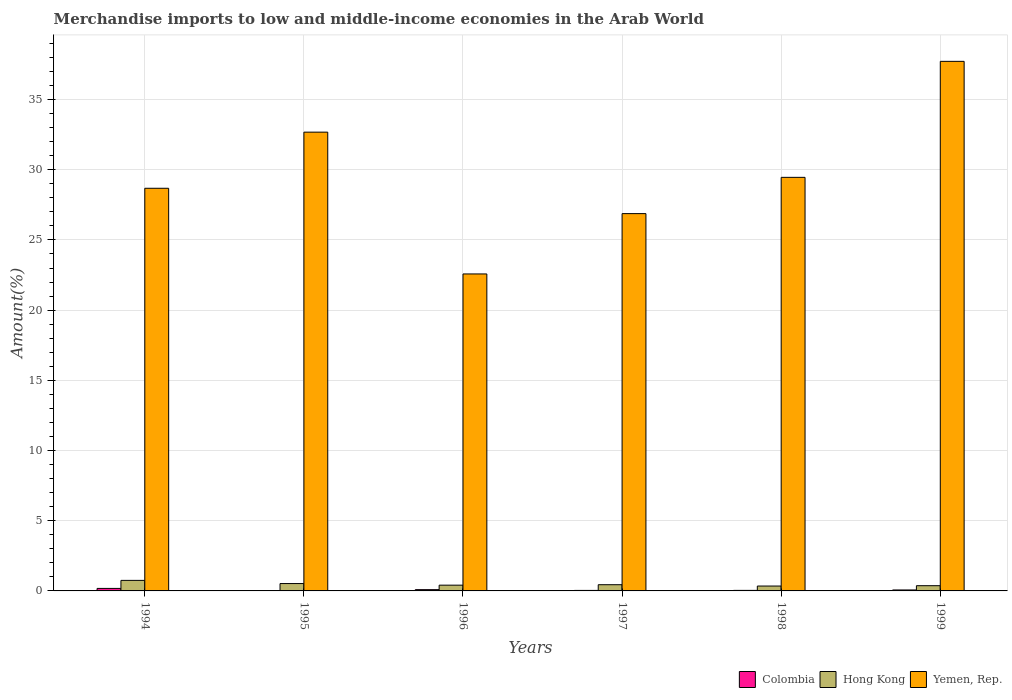How many different coloured bars are there?
Your response must be concise. 3. How many groups of bars are there?
Give a very brief answer. 6. In how many cases, is the number of bars for a given year not equal to the number of legend labels?
Your answer should be very brief. 0. What is the percentage of amount earned from merchandise imports in Colombia in 1994?
Your answer should be very brief. 0.18. Across all years, what is the maximum percentage of amount earned from merchandise imports in Hong Kong?
Offer a very short reply. 0.75. Across all years, what is the minimum percentage of amount earned from merchandise imports in Yemen, Rep.?
Your answer should be compact. 22.58. In which year was the percentage of amount earned from merchandise imports in Yemen, Rep. maximum?
Ensure brevity in your answer.  1999. What is the total percentage of amount earned from merchandise imports in Yemen, Rep. in the graph?
Provide a succinct answer. 178. What is the difference between the percentage of amount earned from merchandise imports in Colombia in 1994 and that in 1999?
Provide a succinct answer. 0.11. What is the difference between the percentage of amount earned from merchandise imports in Yemen, Rep. in 1998 and the percentage of amount earned from merchandise imports in Hong Kong in 1999?
Provide a succinct answer. 29.09. What is the average percentage of amount earned from merchandise imports in Colombia per year?
Your answer should be compact. 0.07. In the year 1997, what is the difference between the percentage of amount earned from merchandise imports in Hong Kong and percentage of amount earned from merchandise imports in Yemen, Rep.?
Ensure brevity in your answer.  -26.43. What is the ratio of the percentage of amount earned from merchandise imports in Yemen, Rep. in 1998 to that in 1999?
Your response must be concise. 0.78. Is the percentage of amount earned from merchandise imports in Hong Kong in 1994 less than that in 1996?
Offer a very short reply. No. What is the difference between the highest and the second highest percentage of amount earned from merchandise imports in Colombia?
Keep it short and to the point. 0.09. What is the difference between the highest and the lowest percentage of amount earned from merchandise imports in Colombia?
Your answer should be very brief. 0.15. In how many years, is the percentage of amount earned from merchandise imports in Colombia greater than the average percentage of amount earned from merchandise imports in Colombia taken over all years?
Provide a succinct answer. 2. Is the sum of the percentage of amount earned from merchandise imports in Colombia in 1994 and 1995 greater than the maximum percentage of amount earned from merchandise imports in Hong Kong across all years?
Ensure brevity in your answer.  No. What does the 2nd bar from the left in 1994 represents?
Provide a succinct answer. Hong Kong. What does the 1st bar from the right in 1997 represents?
Your response must be concise. Yemen, Rep. Is it the case that in every year, the sum of the percentage of amount earned from merchandise imports in Colombia and percentage of amount earned from merchandise imports in Yemen, Rep. is greater than the percentage of amount earned from merchandise imports in Hong Kong?
Ensure brevity in your answer.  Yes. How many bars are there?
Your response must be concise. 18. How many years are there in the graph?
Keep it short and to the point. 6. Does the graph contain any zero values?
Make the answer very short. No. Where does the legend appear in the graph?
Provide a succinct answer. Bottom right. How are the legend labels stacked?
Offer a terse response. Horizontal. What is the title of the graph?
Your answer should be very brief. Merchandise imports to low and middle-income economies in the Arab World. Does "Low & middle income" appear as one of the legend labels in the graph?
Your answer should be very brief. No. What is the label or title of the X-axis?
Provide a succinct answer. Years. What is the label or title of the Y-axis?
Offer a terse response. Amount(%). What is the Amount(%) of Colombia in 1994?
Keep it short and to the point. 0.18. What is the Amount(%) in Hong Kong in 1994?
Provide a short and direct response. 0.75. What is the Amount(%) of Yemen, Rep. in 1994?
Keep it short and to the point. 28.68. What is the Amount(%) of Colombia in 1995?
Your response must be concise. 0.02. What is the Amount(%) of Hong Kong in 1995?
Ensure brevity in your answer.  0.52. What is the Amount(%) in Yemen, Rep. in 1995?
Provide a succinct answer. 32.68. What is the Amount(%) in Colombia in 1996?
Make the answer very short. 0.09. What is the Amount(%) in Hong Kong in 1996?
Give a very brief answer. 0.41. What is the Amount(%) of Yemen, Rep. in 1996?
Ensure brevity in your answer.  22.58. What is the Amount(%) in Colombia in 1997?
Your answer should be very brief. 0.04. What is the Amount(%) in Hong Kong in 1997?
Provide a succinct answer. 0.44. What is the Amount(%) of Yemen, Rep. in 1997?
Provide a short and direct response. 26.88. What is the Amount(%) in Colombia in 1998?
Your answer should be compact. 0.04. What is the Amount(%) in Hong Kong in 1998?
Keep it short and to the point. 0.35. What is the Amount(%) of Yemen, Rep. in 1998?
Offer a terse response. 29.46. What is the Amount(%) in Colombia in 1999?
Ensure brevity in your answer.  0.07. What is the Amount(%) in Hong Kong in 1999?
Provide a short and direct response. 0.37. What is the Amount(%) of Yemen, Rep. in 1999?
Offer a terse response. 37.72. Across all years, what is the maximum Amount(%) in Colombia?
Make the answer very short. 0.18. Across all years, what is the maximum Amount(%) in Hong Kong?
Ensure brevity in your answer.  0.75. Across all years, what is the maximum Amount(%) of Yemen, Rep.?
Give a very brief answer. 37.72. Across all years, what is the minimum Amount(%) of Colombia?
Provide a succinct answer. 0.02. Across all years, what is the minimum Amount(%) of Hong Kong?
Make the answer very short. 0.35. Across all years, what is the minimum Amount(%) in Yemen, Rep.?
Your answer should be compact. 22.58. What is the total Amount(%) of Colombia in the graph?
Offer a very short reply. 0.44. What is the total Amount(%) in Hong Kong in the graph?
Provide a succinct answer. 2.85. What is the total Amount(%) in Yemen, Rep. in the graph?
Make the answer very short. 178. What is the difference between the Amount(%) of Colombia in 1994 and that in 1995?
Offer a terse response. 0.15. What is the difference between the Amount(%) in Hong Kong in 1994 and that in 1995?
Keep it short and to the point. 0.23. What is the difference between the Amount(%) in Yemen, Rep. in 1994 and that in 1995?
Keep it short and to the point. -4. What is the difference between the Amount(%) in Colombia in 1994 and that in 1996?
Make the answer very short. 0.09. What is the difference between the Amount(%) in Hong Kong in 1994 and that in 1996?
Give a very brief answer. 0.34. What is the difference between the Amount(%) of Yemen, Rep. in 1994 and that in 1996?
Your response must be concise. 6.1. What is the difference between the Amount(%) in Colombia in 1994 and that in 1997?
Offer a very short reply. 0.14. What is the difference between the Amount(%) of Hong Kong in 1994 and that in 1997?
Keep it short and to the point. 0.31. What is the difference between the Amount(%) of Yemen, Rep. in 1994 and that in 1997?
Provide a succinct answer. 1.81. What is the difference between the Amount(%) in Colombia in 1994 and that in 1998?
Ensure brevity in your answer.  0.14. What is the difference between the Amount(%) in Hong Kong in 1994 and that in 1998?
Your answer should be very brief. 0.4. What is the difference between the Amount(%) in Yemen, Rep. in 1994 and that in 1998?
Keep it short and to the point. -0.78. What is the difference between the Amount(%) in Colombia in 1994 and that in 1999?
Make the answer very short. 0.11. What is the difference between the Amount(%) in Hong Kong in 1994 and that in 1999?
Offer a terse response. 0.38. What is the difference between the Amount(%) of Yemen, Rep. in 1994 and that in 1999?
Keep it short and to the point. -9.04. What is the difference between the Amount(%) in Colombia in 1995 and that in 1996?
Keep it short and to the point. -0.07. What is the difference between the Amount(%) in Hong Kong in 1995 and that in 1996?
Provide a short and direct response. 0.11. What is the difference between the Amount(%) of Yemen, Rep. in 1995 and that in 1996?
Give a very brief answer. 10.1. What is the difference between the Amount(%) of Colombia in 1995 and that in 1997?
Provide a succinct answer. -0.01. What is the difference between the Amount(%) in Hong Kong in 1995 and that in 1997?
Keep it short and to the point. 0.08. What is the difference between the Amount(%) in Yemen, Rep. in 1995 and that in 1997?
Make the answer very short. 5.8. What is the difference between the Amount(%) in Colombia in 1995 and that in 1998?
Provide a succinct answer. -0.01. What is the difference between the Amount(%) in Hong Kong in 1995 and that in 1998?
Your response must be concise. 0.18. What is the difference between the Amount(%) in Yemen, Rep. in 1995 and that in 1998?
Give a very brief answer. 3.22. What is the difference between the Amount(%) of Colombia in 1995 and that in 1999?
Give a very brief answer. -0.04. What is the difference between the Amount(%) of Hong Kong in 1995 and that in 1999?
Offer a terse response. 0.15. What is the difference between the Amount(%) in Yemen, Rep. in 1995 and that in 1999?
Your response must be concise. -5.04. What is the difference between the Amount(%) of Colombia in 1996 and that in 1997?
Keep it short and to the point. 0.05. What is the difference between the Amount(%) of Hong Kong in 1996 and that in 1997?
Your response must be concise. -0.03. What is the difference between the Amount(%) in Yemen, Rep. in 1996 and that in 1997?
Your answer should be compact. -4.3. What is the difference between the Amount(%) in Colombia in 1996 and that in 1998?
Ensure brevity in your answer.  0.05. What is the difference between the Amount(%) in Hong Kong in 1996 and that in 1998?
Offer a very short reply. 0.06. What is the difference between the Amount(%) in Yemen, Rep. in 1996 and that in 1998?
Offer a very short reply. -6.88. What is the difference between the Amount(%) in Colombia in 1996 and that in 1999?
Ensure brevity in your answer.  0.02. What is the difference between the Amount(%) of Hong Kong in 1996 and that in 1999?
Your answer should be compact. 0.04. What is the difference between the Amount(%) in Yemen, Rep. in 1996 and that in 1999?
Offer a very short reply. -15.14. What is the difference between the Amount(%) of Colombia in 1997 and that in 1998?
Provide a succinct answer. -0. What is the difference between the Amount(%) of Hong Kong in 1997 and that in 1998?
Ensure brevity in your answer.  0.1. What is the difference between the Amount(%) in Yemen, Rep. in 1997 and that in 1998?
Offer a terse response. -2.58. What is the difference between the Amount(%) of Colombia in 1997 and that in 1999?
Provide a succinct answer. -0.03. What is the difference between the Amount(%) in Hong Kong in 1997 and that in 1999?
Offer a terse response. 0.07. What is the difference between the Amount(%) of Yemen, Rep. in 1997 and that in 1999?
Make the answer very short. -10.85. What is the difference between the Amount(%) of Colombia in 1998 and that in 1999?
Offer a very short reply. -0.03. What is the difference between the Amount(%) in Hong Kong in 1998 and that in 1999?
Give a very brief answer. -0.02. What is the difference between the Amount(%) of Yemen, Rep. in 1998 and that in 1999?
Provide a succinct answer. -8.26. What is the difference between the Amount(%) in Colombia in 1994 and the Amount(%) in Hong Kong in 1995?
Give a very brief answer. -0.35. What is the difference between the Amount(%) of Colombia in 1994 and the Amount(%) of Yemen, Rep. in 1995?
Make the answer very short. -32.5. What is the difference between the Amount(%) in Hong Kong in 1994 and the Amount(%) in Yemen, Rep. in 1995?
Offer a very short reply. -31.93. What is the difference between the Amount(%) in Colombia in 1994 and the Amount(%) in Hong Kong in 1996?
Offer a very short reply. -0.23. What is the difference between the Amount(%) of Colombia in 1994 and the Amount(%) of Yemen, Rep. in 1996?
Your response must be concise. -22.4. What is the difference between the Amount(%) of Hong Kong in 1994 and the Amount(%) of Yemen, Rep. in 1996?
Give a very brief answer. -21.83. What is the difference between the Amount(%) of Colombia in 1994 and the Amount(%) of Hong Kong in 1997?
Provide a succinct answer. -0.26. What is the difference between the Amount(%) of Colombia in 1994 and the Amount(%) of Yemen, Rep. in 1997?
Make the answer very short. -26.7. What is the difference between the Amount(%) in Hong Kong in 1994 and the Amount(%) in Yemen, Rep. in 1997?
Give a very brief answer. -26.13. What is the difference between the Amount(%) in Colombia in 1994 and the Amount(%) in Hong Kong in 1998?
Provide a succinct answer. -0.17. What is the difference between the Amount(%) in Colombia in 1994 and the Amount(%) in Yemen, Rep. in 1998?
Offer a terse response. -29.28. What is the difference between the Amount(%) in Hong Kong in 1994 and the Amount(%) in Yemen, Rep. in 1998?
Your response must be concise. -28.71. What is the difference between the Amount(%) in Colombia in 1994 and the Amount(%) in Hong Kong in 1999?
Offer a terse response. -0.19. What is the difference between the Amount(%) of Colombia in 1994 and the Amount(%) of Yemen, Rep. in 1999?
Give a very brief answer. -37.54. What is the difference between the Amount(%) in Hong Kong in 1994 and the Amount(%) in Yemen, Rep. in 1999?
Offer a very short reply. -36.97. What is the difference between the Amount(%) of Colombia in 1995 and the Amount(%) of Hong Kong in 1996?
Provide a succinct answer. -0.39. What is the difference between the Amount(%) of Colombia in 1995 and the Amount(%) of Yemen, Rep. in 1996?
Your answer should be compact. -22.55. What is the difference between the Amount(%) in Hong Kong in 1995 and the Amount(%) in Yemen, Rep. in 1996?
Make the answer very short. -22.05. What is the difference between the Amount(%) in Colombia in 1995 and the Amount(%) in Hong Kong in 1997?
Make the answer very short. -0.42. What is the difference between the Amount(%) of Colombia in 1995 and the Amount(%) of Yemen, Rep. in 1997?
Your answer should be compact. -26.85. What is the difference between the Amount(%) of Hong Kong in 1995 and the Amount(%) of Yemen, Rep. in 1997?
Ensure brevity in your answer.  -26.35. What is the difference between the Amount(%) in Colombia in 1995 and the Amount(%) in Hong Kong in 1998?
Your answer should be compact. -0.32. What is the difference between the Amount(%) of Colombia in 1995 and the Amount(%) of Yemen, Rep. in 1998?
Keep it short and to the point. -29.43. What is the difference between the Amount(%) in Hong Kong in 1995 and the Amount(%) in Yemen, Rep. in 1998?
Ensure brevity in your answer.  -28.93. What is the difference between the Amount(%) of Colombia in 1995 and the Amount(%) of Hong Kong in 1999?
Offer a very short reply. -0.35. What is the difference between the Amount(%) of Colombia in 1995 and the Amount(%) of Yemen, Rep. in 1999?
Provide a short and direct response. -37.7. What is the difference between the Amount(%) in Hong Kong in 1995 and the Amount(%) in Yemen, Rep. in 1999?
Your answer should be compact. -37.2. What is the difference between the Amount(%) in Colombia in 1996 and the Amount(%) in Hong Kong in 1997?
Offer a terse response. -0.35. What is the difference between the Amount(%) in Colombia in 1996 and the Amount(%) in Yemen, Rep. in 1997?
Keep it short and to the point. -26.79. What is the difference between the Amount(%) in Hong Kong in 1996 and the Amount(%) in Yemen, Rep. in 1997?
Offer a terse response. -26.47. What is the difference between the Amount(%) in Colombia in 1996 and the Amount(%) in Hong Kong in 1998?
Offer a terse response. -0.26. What is the difference between the Amount(%) in Colombia in 1996 and the Amount(%) in Yemen, Rep. in 1998?
Provide a succinct answer. -29.37. What is the difference between the Amount(%) of Hong Kong in 1996 and the Amount(%) of Yemen, Rep. in 1998?
Your answer should be compact. -29.05. What is the difference between the Amount(%) of Colombia in 1996 and the Amount(%) of Hong Kong in 1999?
Provide a short and direct response. -0.28. What is the difference between the Amount(%) in Colombia in 1996 and the Amount(%) in Yemen, Rep. in 1999?
Offer a terse response. -37.63. What is the difference between the Amount(%) of Hong Kong in 1996 and the Amount(%) of Yemen, Rep. in 1999?
Your answer should be very brief. -37.31. What is the difference between the Amount(%) in Colombia in 1997 and the Amount(%) in Hong Kong in 1998?
Give a very brief answer. -0.31. What is the difference between the Amount(%) of Colombia in 1997 and the Amount(%) of Yemen, Rep. in 1998?
Offer a very short reply. -29.42. What is the difference between the Amount(%) of Hong Kong in 1997 and the Amount(%) of Yemen, Rep. in 1998?
Give a very brief answer. -29.02. What is the difference between the Amount(%) in Colombia in 1997 and the Amount(%) in Hong Kong in 1999?
Your response must be concise. -0.34. What is the difference between the Amount(%) of Colombia in 1997 and the Amount(%) of Yemen, Rep. in 1999?
Provide a succinct answer. -37.69. What is the difference between the Amount(%) in Hong Kong in 1997 and the Amount(%) in Yemen, Rep. in 1999?
Provide a succinct answer. -37.28. What is the difference between the Amount(%) in Colombia in 1998 and the Amount(%) in Hong Kong in 1999?
Provide a short and direct response. -0.33. What is the difference between the Amount(%) in Colombia in 1998 and the Amount(%) in Yemen, Rep. in 1999?
Give a very brief answer. -37.68. What is the difference between the Amount(%) of Hong Kong in 1998 and the Amount(%) of Yemen, Rep. in 1999?
Provide a succinct answer. -37.37. What is the average Amount(%) in Colombia per year?
Your answer should be very brief. 0.07. What is the average Amount(%) in Hong Kong per year?
Your answer should be compact. 0.47. What is the average Amount(%) in Yemen, Rep. per year?
Give a very brief answer. 29.67. In the year 1994, what is the difference between the Amount(%) in Colombia and Amount(%) in Hong Kong?
Ensure brevity in your answer.  -0.57. In the year 1994, what is the difference between the Amount(%) in Colombia and Amount(%) in Yemen, Rep.?
Keep it short and to the point. -28.5. In the year 1994, what is the difference between the Amount(%) in Hong Kong and Amount(%) in Yemen, Rep.?
Your answer should be compact. -27.93. In the year 1995, what is the difference between the Amount(%) in Colombia and Amount(%) in Hong Kong?
Keep it short and to the point. -0.5. In the year 1995, what is the difference between the Amount(%) of Colombia and Amount(%) of Yemen, Rep.?
Offer a very short reply. -32.65. In the year 1995, what is the difference between the Amount(%) of Hong Kong and Amount(%) of Yemen, Rep.?
Provide a short and direct response. -32.15. In the year 1996, what is the difference between the Amount(%) in Colombia and Amount(%) in Hong Kong?
Give a very brief answer. -0.32. In the year 1996, what is the difference between the Amount(%) in Colombia and Amount(%) in Yemen, Rep.?
Keep it short and to the point. -22.49. In the year 1996, what is the difference between the Amount(%) in Hong Kong and Amount(%) in Yemen, Rep.?
Your response must be concise. -22.17. In the year 1997, what is the difference between the Amount(%) of Colombia and Amount(%) of Hong Kong?
Make the answer very short. -0.41. In the year 1997, what is the difference between the Amount(%) of Colombia and Amount(%) of Yemen, Rep.?
Offer a very short reply. -26.84. In the year 1997, what is the difference between the Amount(%) of Hong Kong and Amount(%) of Yemen, Rep.?
Your response must be concise. -26.43. In the year 1998, what is the difference between the Amount(%) of Colombia and Amount(%) of Hong Kong?
Ensure brevity in your answer.  -0.31. In the year 1998, what is the difference between the Amount(%) of Colombia and Amount(%) of Yemen, Rep.?
Provide a succinct answer. -29.42. In the year 1998, what is the difference between the Amount(%) in Hong Kong and Amount(%) in Yemen, Rep.?
Your answer should be very brief. -29.11. In the year 1999, what is the difference between the Amount(%) in Colombia and Amount(%) in Hong Kong?
Offer a very short reply. -0.3. In the year 1999, what is the difference between the Amount(%) in Colombia and Amount(%) in Yemen, Rep.?
Your answer should be compact. -37.65. In the year 1999, what is the difference between the Amount(%) in Hong Kong and Amount(%) in Yemen, Rep.?
Give a very brief answer. -37.35. What is the ratio of the Amount(%) of Colombia in 1994 to that in 1995?
Ensure brevity in your answer.  7.16. What is the ratio of the Amount(%) in Hong Kong in 1994 to that in 1995?
Your answer should be compact. 1.43. What is the ratio of the Amount(%) of Yemen, Rep. in 1994 to that in 1995?
Give a very brief answer. 0.88. What is the ratio of the Amount(%) of Colombia in 1994 to that in 1996?
Give a very brief answer. 1.97. What is the ratio of the Amount(%) in Hong Kong in 1994 to that in 1996?
Provide a succinct answer. 1.83. What is the ratio of the Amount(%) of Yemen, Rep. in 1994 to that in 1996?
Your response must be concise. 1.27. What is the ratio of the Amount(%) of Colombia in 1994 to that in 1997?
Your answer should be compact. 4.93. What is the ratio of the Amount(%) in Hong Kong in 1994 to that in 1997?
Provide a succinct answer. 1.7. What is the ratio of the Amount(%) in Yemen, Rep. in 1994 to that in 1997?
Offer a very short reply. 1.07. What is the ratio of the Amount(%) in Colombia in 1994 to that in 1998?
Your response must be concise. 4.73. What is the ratio of the Amount(%) of Hong Kong in 1994 to that in 1998?
Your response must be concise. 2.16. What is the ratio of the Amount(%) in Yemen, Rep. in 1994 to that in 1998?
Offer a terse response. 0.97. What is the ratio of the Amount(%) in Colombia in 1994 to that in 1999?
Keep it short and to the point. 2.61. What is the ratio of the Amount(%) of Hong Kong in 1994 to that in 1999?
Make the answer very short. 2.02. What is the ratio of the Amount(%) in Yemen, Rep. in 1994 to that in 1999?
Your answer should be compact. 0.76. What is the ratio of the Amount(%) in Colombia in 1995 to that in 1996?
Give a very brief answer. 0.28. What is the ratio of the Amount(%) of Hong Kong in 1995 to that in 1996?
Your answer should be compact. 1.28. What is the ratio of the Amount(%) of Yemen, Rep. in 1995 to that in 1996?
Offer a terse response. 1.45. What is the ratio of the Amount(%) of Colombia in 1995 to that in 1997?
Offer a very short reply. 0.69. What is the ratio of the Amount(%) in Hong Kong in 1995 to that in 1997?
Offer a very short reply. 1.18. What is the ratio of the Amount(%) in Yemen, Rep. in 1995 to that in 1997?
Provide a short and direct response. 1.22. What is the ratio of the Amount(%) of Colombia in 1995 to that in 1998?
Ensure brevity in your answer.  0.66. What is the ratio of the Amount(%) of Hong Kong in 1995 to that in 1998?
Your answer should be compact. 1.51. What is the ratio of the Amount(%) of Yemen, Rep. in 1995 to that in 1998?
Offer a terse response. 1.11. What is the ratio of the Amount(%) in Colombia in 1995 to that in 1999?
Provide a succinct answer. 0.37. What is the ratio of the Amount(%) of Hong Kong in 1995 to that in 1999?
Offer a very short reply. 1.41. What is the ratio of the Amount(%) of Yemen, Rep. in 1995 to that in 1999?
Make the answer very short. 0.87. What is the ratio of the Amount(%) of Colombia in 1996 to that in 1997?
Keep it short and to the point. 2.5. What is the ratio of the Amount(%) in Hong Kong in 1996 to that in 1997?
Offer a very short reply. 0.93. What is the ratio of the Amount(%) in Yemen, Rep. in 1996 to that in 1997?
Provide a succinct answer. 0.84. What is the ratio of the Amount(%) in Colombia in 1996 to that in 1998?
Your answer should be compact. 2.4. What is the ratio of the Amount(%) in Hong Kong in 1996 to that in 1998?
Make the answer very short. 1.18. What is the ratio of the Amount(%) of Yemen, Rep. in 1996 to that in 1998?
Make the answer very short. 0.77. What is the ratio of the Amount(%) in Colombia in 1996 to that in 1999?
Your answer should be compact. 1.32. What is the ratio of the Amount(%) of Hong Kong in 1996 to that in 1999?
Provide a succinct answer. 1.1. What is the ratio of the Amount(%) in Yemen, Rep. in 1996 to that in 1999?
Provide a succinct answer. 0.6. What is the ratio of the Amount(%) in Hong Kong in 1997 to that in 1998?
Ensure brevity in your answer.  1.27. What is the ratio of the Amount(%) in Yemen, Rep. in 1997 to that in 1998?
Make the answer very short. 0.91. What is the ratio of the Amount(%) in Colombia in 1997 to that in 1999?
Keep it short and to the point. 0.53. What is the ratio of the Amount(%) of Hong Kong in 1997 to that in 1999?
Keep it short and to the point. 1.19. What is the ratio of the Amount(%) in Yemen, Rep. in 1997 to that in 1999?
Make the answer very short. 0.71. What is the ratio of the Amount(%) in Colombia in 1998 to that in 1999?
Offer a terse response. 0.55. What is the ratio of the Amount(%) in Hong Kong in 1998 to that in 1999?
Provide a succinct answer. 0.93. What is the ratio of the Amount(%) of Yemen, Rep. in 1998 to that in 1999?
Offer a very short reply. 0.78. What is the difference between the highest and the second highest Amount(%) of Colombia?
Keep it short and to the point. 0.09. What is the difference between the highest and the second highest Amount(%) in Hong Kong?
Provide a short and direct response. 0.23. What is the difference between the highest and the second highest Amount(%) of Yemen, Rep.?
Your answer should be compact. 5.04. What is the difference between the highest and the lowest Amount(%) of Colombia?
Give a very brief answer. 0.15. What is the difference between the highest and the lowest Amount(%) of Hong Kong?
Your answer should be compact. 0.4. What is the difference between the highest and the lowest Amount(%) in Yemen, Rep.?
Ensure brevity in your answer.  15.14. 